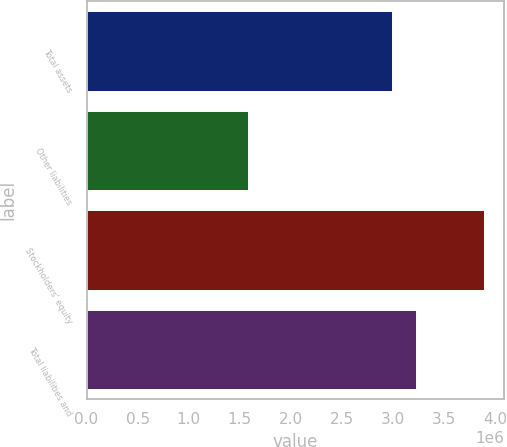<chart> <loc_0><loc_0><loc_500><loc_500><bar_chart><fcel>Total assets<fcel>Other liabilities<fcel>Stockholders' equity<fcel>Total liabilities and<nl><fcel>2.99198e+06<fcel>1.57846e+06<fcel>3.89072e+06<fcel>3.22321e+06<nl></chart> 